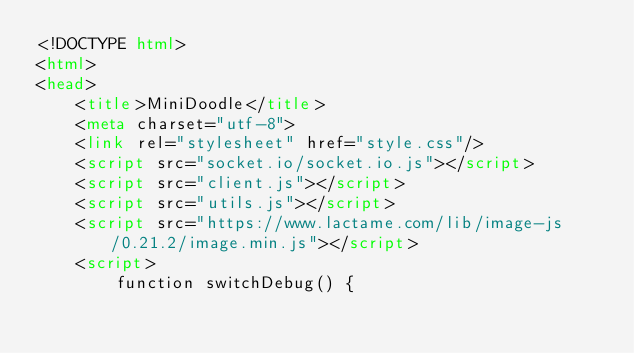<code> <loc_0><loc_0><loc_500><loc_500><_HTML_><!DOCTYPE html>
<html>
<head>
    <title>MiniDoodle</title>
    <meta charset="utf-8">
    <link rel="stylesheet" href="style.css"/>
    <script src="socket.io/socket.io.js"></script>
    <script src="client.js"></script>
    <script src="utils.js"></script>
    <script src="https://www.lactame.com/lib/image-js/0.21.2/image.min.js"></script>
    <script>
        function switchDebug() {</code> 